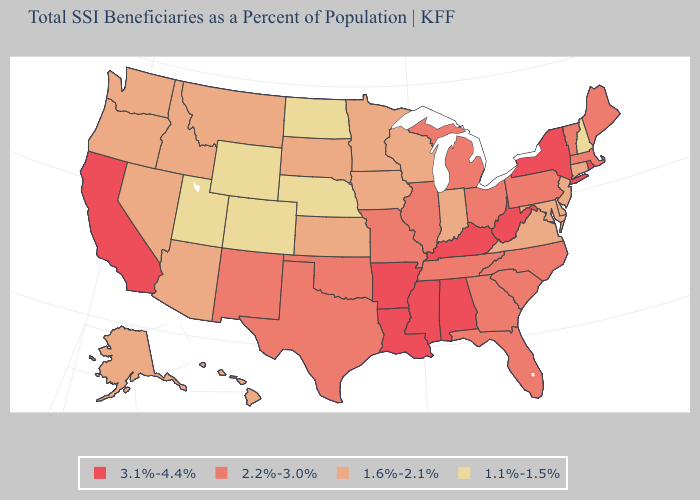Which states have the lowest value in the West?
Short answer required. Colorado, Utah, Wyoming. What is the highest value in states that border Ohio?
Concise answer only. 3.1%-4.4%. What is the value of New Mexico?
Quick response, please. 2.2%-3.0%. Does Wyoming have the same value as Colorado?
Give a very brief answer. Yes. Does Massachusetts have the highest value in the USA?
Concise answer only. No. Among the states that border New Jersey , which have the lowest value?
Give a very brief answer. Delaware. What is the highest value in the USA?
Write a very short answer. 3.1%-4.4%. Name the states that have a value in the range 1.6%-2.1%?
Answer briefly. Alaska, Arizona, Connecticut, Delaware, Hawaii, Idaho, Indiana, Iowa, Kansas, Maryland, Minnesota, Montana, Nevada, New Jersey, Oregon, South Dakota, Virginia, Washington, Wisconsin. Is the legend a continuous bar?
Be succinct. No. What is the value of Indiana?
Quick response, please. 1.6%-2.1%. Does Indiana have the same value as Alaska?
Write a very short answer. Yes. What is the value of Arkansas?
Keep it brief. 3.1%-4.4%. What is the lowest value in the MidWest?
Write a very short answer. 1.1%-1.5%. Name the states that have a value in the range 1.6%-2.1%?
Answer briefly. Alaska, Arizona, Connecticut, Delaware, Hawaii, Idaho, Indiana, Iowa, Kansas, Maryland, Minnesota, Montana, Nevada, New Jersey, Oregon, South Dakota, Virginia, Washington, Wisconsin. Does Wyoming have the lowest value in the USA?
Be succinct. Yes. 